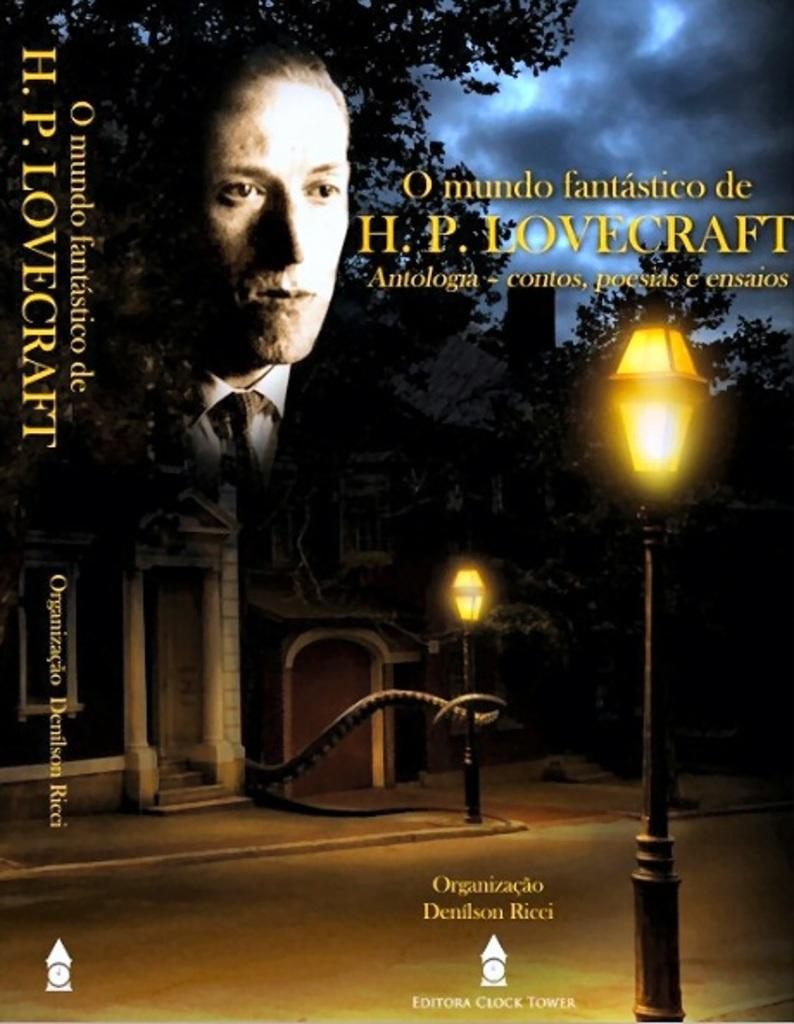<image>
Offer a succinct explanation of the picture presented. Editora Clock Tower published a book by H. P. Lovecraft. 